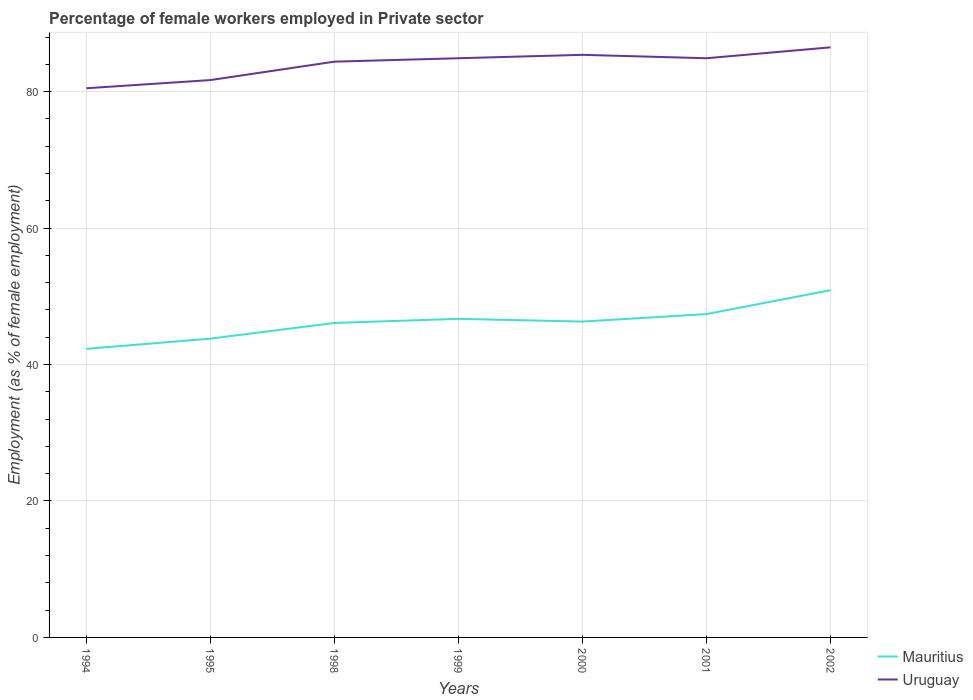Does the line corresponding to Mauritius intersect with the line corresponding to Uruguay?
Keep it short and to the point. No. Is the number of lines equal to the number of legend labels?
Your answer should be compact. Yes. Across all years, what is the maximum percentage of females employed in Private sector in Mauritius?
Provide a succinct answer. 42.3. What is the difference between the highest and the second highest percentage of females employed in Private sector in Mauritius?
Offer a terse response. 8.6. What is the difference between the highest and the lowest percentage of females employed in Private sector in Uruguay?
Your response must be concise. 5. How many years are there in the graph?
Offer a very short reply. 7. Where does the legend appear in the graph?
Offer a very short reply. Bottom right. What is the title of the graph?
Your response must be concise. Percentage of female workers employed in Private sector. What is the label or title of the X-axis?
Make the answer very short. Years. What is the label or title of the Y-axis?
Provide a short and direct response. Employment (as % of female employment). What is the Employment (as % of female employment) of Mauritius in 1994?
Provide a succinct answer. 42.3. What is the Employment (as % of female employment) of Uruguay in 1994?
Ensure brevity in your answer.  80.5. What is the Employment (as % of female employment) of Mauritius in 1995?
Give a very brief answer. 43.8. What is the Employment (as % of female employment) in Uruguay in 1995?
Ensure brevity in your answer.  81.7. What is the Employment (as % of female employment) in Mauritius in 1998?
Your answer should be very brief. 46.1. What is the Employment (as % of female employment) of Uruguay in 1998?
Provide a succinct answer. 84.4. What is the Employment (as % of female employment) in Mauritius in 1999?
Your answer should be very brief. 46.7. What is the Employment (as % of female employment) in Uruguay in 1999?
Offer a terse response. 84.9. What is the Employment (as % of female employment) of Mauritius in 2000?
Your response must be concise. 46.3. What is the Employment (as % of female employment) of Uruguay in 2000?
Your response must be concise. 85.4. What is the Employment (as % of female employment) of Mauritius in 2001?
Offer a very short reply. 47.4. What is the Employment (as % of female employment) of Uruguay in 2001?
Offer a terse response. 84.9. What is the Employment (as % of female employment) of Mauritius in 2002?
Your answer should be compact. 50.9. What is the Employment (as % of female employment) in Uruguay in 2002?
Provide a succinct answer. 86.5. Across all years, what is the maximum Employment (as % of female employment) of Mauritius?
Give a very brief answer. 50.9. Across all years, what is the maximum Employment (as % of female employment) of Uruguay?
Provide a succinct answer. 86.5. Across all years, what is the minimum Employment (as % of female employment) in Mauritius?
Your answer should be very brief. 42.3. Across all years, what is the minimum Employment (as % of female employment) of Uruguay?
Offer a very short reply. 80.5. What is the total Employment (as % of female employment) in Mauritius in the graph?
Your response must be concise. 323.5. What is the total Employment (as % of female employment) in Uruguay in the graph?
Ensure brevity in your answer.  588.3. What is the difference between the Employment (as % of female employment) of Uruguay in 1994 and that in 1998?
Offer a very short reply. -3.9. What is the difference between the Employment (as % of female employment) of Mauritius in 1994 and that in 1999?
Provide a succinct answer. -4.4. What is the difference between the Employment (as % of female employment) of Mauritius in 1994 and that in 2000?
Offer a very short reply. -4. What is the difference between the Employment (as % of female employment) in Uruguay in 1994 and that in 2000?
Offer a terse response. -4.9. What is the difference between the Employment (as % of female employment) in Uruguay in 1994 and that in 2001?
Make the answer very short. -4.4. What is the difference between the Employment (as % of female employment) of Mauritius in 1994 and that in 2002?
Offer a terse response. -8.6. What is the difference between the Employment (as % of female employment) of Uruguay in 1995 and that in 1998?
Make the answer very short. -2.7. What is the difference between the Employment (as % of female employment) in Uruguay in 1995 and that in 1999?
Offer a very short reply. -3.2. What is the difference between the Employment (as % of female employment) of Mauritius in 1995 and that in 2001?
Keep it short and to the point. -3.6. What is the difference between the Employment (as % of female employment) of Uruguay in 1995 and that in 2002?
Keep it short and to the point. -4.8. What is the difference between the Employment (as % of female employment) in Uruguay in 1998 and that in 1999?
Offer a terse response. -0.5. What is the difference between the Employment (as % of female employment) in Mauritius in 1998 and that in 2000?
Offer a very short reply. -0.2. What is the difference between the Employment (as % of female employment) of Mauritius in 1998 and that in 2002?
Keep it short and to the point. -4.8. What is the difference between the Employment (as % of female employment) in Uruguay in 1999 and that in 2000?
Keep it short and to the point. -0.5. What is the difference between the Employment (as % of female employment) in Mauritius in 1999 and that in 2001?
Give a very brief answer. -0.7. What is the difference between the Employment (as % of female employment) of Mauritius in 2000 and that in 2001?
Ensure brevity in your answer.  -1.1. What is the difference between the Employment (as % of female employment) of Mauritius in 2000 and that in 2002?
Provide a short and direct response. -4.6. What is the difference between the Employment (as % of female employment) of Uruguay in 2000 and that in 2002?
Ensure brevity in your answer.  -1.1. What is the difference between the Employment (as % of female employment) in Uruguay in 2001 and that in 2002?
Provide a short and direct response. -1.6. What is the difference between the Employment (as % of female employment) of Mauritius in 1994 and the Employment (as % of female employment) of Uruguay in 1995?
Offer a very short reply. -39.4. What is the difference between the Employment (as % of female employment) of Mauritius in 1994 and the Employment (as % of female employment) of Uruguay in 1998?
Your answer should be compact. -42.1. What is the difference between the Employment (as % of female employment) of Mauritius in 1994 and the Employment (as % of female employment) of Uruguay in 1999?
Your response must be concise. -42.6. What is the difference between the Employment (as % of female employment) in Mauritius in 1994 and the Employment (as % of female employment) in Uruguay in 2000?
Ensure brevity in your answer.  -43.1. What is the difference between the Employment (as % of female employment) in Mauritius in 1994 and the Employment (as % of female employment) in Uruguay in 2001?
Give a very brief answer. -42.6. What is the difference between the Employment (as % of female employment) in Mauritius in 1994 and the Employment (as % of female employment) in Uruguay in 2002?
Your answer should be very brief. -44.2. What is the difference between the Employment (as % of female employment) of Mauritius in 1995 and the Employment (as % of female employment) of Uruguay in 1998?
Keep it short and to the point. -40.6. What is the difference between the Employment (as % of female employment) in Mauritius in 1995 and the Employment (as % of female employment) in Uruguay in 1999?
Keep it short and to the point. -41.1. What is the difference between the Employment (as % of female employment) in Mauritius in 1995 and the Employment (as % of female employment) in Uruguay in 2000?
Give a very brief answer. -41.6. What is the difference between the Employment (as % of female employment) in Mauritius in 1995 and the Employment (as % of female employment) in Uruguay in 2001?
Your answer should be very brief. -41.1. What is the difference between the Employment (as % of female employment) of Mauritius in 1995 and the Employment (as % of female employment) of Uruguay in 2002?
Provide a short and direct response. -42.7. What is the difference between the Employment (as % of female employment) in Mauritius in 1998 and the Employment (as % of female employment) in Uruguay in 1999?
Offer a very short reply. -38.8. What is the difference between the Employment (as % of female employment) in Mauritius in 1998 and the Employment (as % of female employment) in Uruguay in 2000?
Your answer should be very brief. -39.3. What is the difference between the Employment (as % of female employment) of Mauritius in 1998 and the Employment (as % of female employment) of Uruguay in 2001?
Your answer should be very brief. -38.8. What is the difference between the Employment (as % of female employment) in Mauritius in 1998 and the Employment (as % of female employment) in Uruguay in 2002?
Your answer should be very brief. -40.4. What is the difference between the Employment (as % of female employment) in Mauritius in 1999 and the Employment (as % of female employment) in Uruguay in 2000?
Your answer should be compact. -38.7. What is the difference between the Employment (as % of female employment) of Mauritius in 1999 and the Employment (as % of female employment) of Uruguay in 2001?
Make the answer very short. -38.2. What is the difference between the Employment (as % of female employment) of Mauritius in 1999 and the Employment (as % of female employment) of Uruguay in 2002?
Keep it short and to the point. -39.8. What is the difference between the Employment (as % of female employment) of Mauritius in 2000 and the Employment (as % of female employment) of Uruguay in 2001?
Make the answer very short. -38.6. What is the difference between the Employment (as % of female employment) in Mauritius in 2000 and the Employment (as % of female employment) in Uruguay in 2002?
Your answer should be very brief. -40.2. What is the difference between the Employment (as % of female employment) in Mauritius in 2001 and the Employment (as % of female employment) in Uruguay in 2002?
Give a very brief answer. -39.1. What is the average Employment (as % of female employment) in Mauritius per year?
Provide a succinct answer. 46.21. What is the average Employment (as % of female employment) of Uruguay per year?
Provide a short and direct response. 84.04. In the year 1994, what is the difference between the Employment (as % of female employment) in Mauritius and Employment (as % of female employment) in Uruguay?
Make the answer very short. -38.2. In the year 1995, what is the difference between the Employment (as % of female employment) of Mauritius and Employment (as % of female employment) of Uruguay?
Provide a short and direct response. -37.9. In the year 1998, what is the difference between the Employment (as % of female employment) in Mauritius and Employment (as % of female employment) in Uruguay?
Your answer should be very brief. -38.3. In the year 1999, what is the difference between the Employment (as % of female employment) in Mauritius and Employment (as % of female employment) in Uruguay?
Make the answer very short. -38.2. In the year 2000, what is the difference between the Employment (as % of female employment) of Mauritius and Employment (as % of female employment) of Uruguay?
Provide a succinct answer. -39.1. In the year 2001, what is the difference between the Employment (as % of female employment) in Mauritius and Employment (as % of female employment) in Uruguay?
Make the answer very short. -37.5. In the year 2002, what is the difference between the Employment (as % of female employment) in Mauritius and Employment (as % of female employment) in Uruguay?
Keep it short and to the point. -35.6. What is the ratio of the Employment (as % of female employment) of Mauritius in 1994 to that in 1995?
Make the answer very short. 0.97. What is the ratio of the Employment (as % of female employment) of Mauritius in 1994 to that in 1998?
Provide a succinct answer. 0.92. What is the ratio of the Employment (as % of female employment) in Uruguay in 1994 to that in 1998?
Make the answer very short. 0.95. What is the ratio of the Employment (as % of female employment) of Mauritius in 1994 to that in 1999?
Offer a terse response. 0.91. What is the ratio of the Employment (as % of female employment) of Uruguay in 1994 to that in 1999?
Make the answer very short. 0.95. What is the ratio of the Employment (as % of female employment) in Mauritius in 1994 to that in 2000?
Offer a very short reply. 0.91. What is the ratio of the Employment (as % of female employment) of Uruguay in 1994 to that in 2000?
Provide a succinct answer. 0.94. What is the ratio of the Employment (as % of female employment) of Mauritius in 1994 to that in 2001?
Provide a short and direct response. 0.89. What is the ratio of the Employment (as % of female employment) in Uruguay in 1994 to that in 2001?
Keep it short and to the point. 0.95. What is the ratio of the Employment (as % of female employment) in Mauritius in 1994 to that in 2002?
Offer a terse response. 0.83. What is the ratio of the Employment (as % of female employment) of Uruguay in 1994 to that in 2002?
Make the answer very short. 0.93. What is the ratio of the Employment (as % of female employment) of Mauritius in 1995 to that in 1998?
Your answer should be compact. 0.95. What is the ratio of the Employment (as % of female employment) of Uruguay in 1995 to that in 1998?
Your answer should be compact. 0.97. What is the ratio of the Employment (as % of female employment) of Mauritius in 1995 to that in 1999?
Provide a succinct answer. 0.94. What is the ratio of the Employment (as % of female employment) of Uruguay in 1995 to that in 1999?
Provide a succinct answer. 0.96. What is the ratio of the Employment (as % of female employment) of Mauritius in 1995 to that in 2000?
Keep it short and to the point. 0.95. What is the ratio of the Employment (as % of female employment) of Uruguay in 1995 to that in 2000?
Keep it short and to the point. 0.96. What is the ratio of the Employment (as % of female employment) in Mauritius in 1995 to that in 2001?
Your response must be concise. 0.92. What is the ratio of the Employment (as % of female employment) in Uruguay in 1995 to that in 2001?
Ensure brevity in your answer.  0.96. What is the ratio of the Employment (as % of female employment) of Mauritius in 1995 to that in 2002?
Offer a very short reply. 0.86. What is the ratio of the Employment (as % of female employment) in Uruguay in 1995 to that in 2002?
Provide a short and direct response. 0.94. What is the ratio of the Employment (as % of female employment) in Mauritius in 1998 to that in 1999?
Provide a succinct answer. 0.99. What is the ratio of the Employment (as % of female employment) of Uruguay in 1998 to that in 1999?
Your response must be concise. 0.99. What is the ratio of the Employment (as % of female employment) in Uruguay in 1998 to that in 2000?
Ensure brevity in your answer.  0.99. What is the ratio of the Employment (as % of female employment) of Mauritius in 1998 to that in 2001?
Your answer should be compact. 0.97. What is the ratio of the Employment (as % of female employment) in Mauritius in 1998 to that in 2002?
Offer a terse response. 0.91. What is the ratio of the Employment (as % of female employment) in Uruguay in 1998 to that in 2002?
Offer a terse response. 0.98. What is the ratio of the Employment (as % of female employment) of Mauritius in 1999 to that in 2000?
Offer a terse response. 1.01. What is the ratio of the Employment (as % of female employment) of Uruguay in 1999 to that in 2000?
Your answer should be compact. 0.99. What is the ratio of the Employment (as % of female employment) in Mauritius in 1999 to that in 2001?
Provide a short and direct response. 0.99. What is the ratio of the Employment (as % of female employment) of Mauritius in 1999 to that in 2002?
Offer a very short reply. 0.92. What is the ratio of the Employment (as % of female employment) of Uruguay in 1999 to that in 2002?
Make the answer very short. 0.98. What is the ratio of the Employment (as % of female employment) of Mauritius in 2000 to that in 2001?
Your response must be concise. 0.98. What is the ratio of the Employment (as % of female employment) in Uruguay in 2000 to that in 2001?
Your response must be concise. 1.01. What is the ratio of the Employment (as % of female employment) in Mauritius in 2000 to that in 2002?
Keep it short and to the point. 0.91. What is the ratio of the Employment (as % of female employment) of Uruguay in 2000 to that in 2002?
Your answer should be compact. 0.99. What is the ratio of the Employment (as % of female employment) in Mauritius in 2001 to that in 2002?
Provide a succinct answer. 0.93. What is the ratio of the Employment (as % of female employment) in Uruguay in 2001 to that in 2002?
Offer a terse response. 0.98. What is the difference between the highest and the second highest Employment (as % of female employment) of Mauritius?
Your response must be concise. 3.5. What is the difference between the highest and the lowest Employment (as % of female employment) of Uruguay?
Your answer should be compact. 6. 